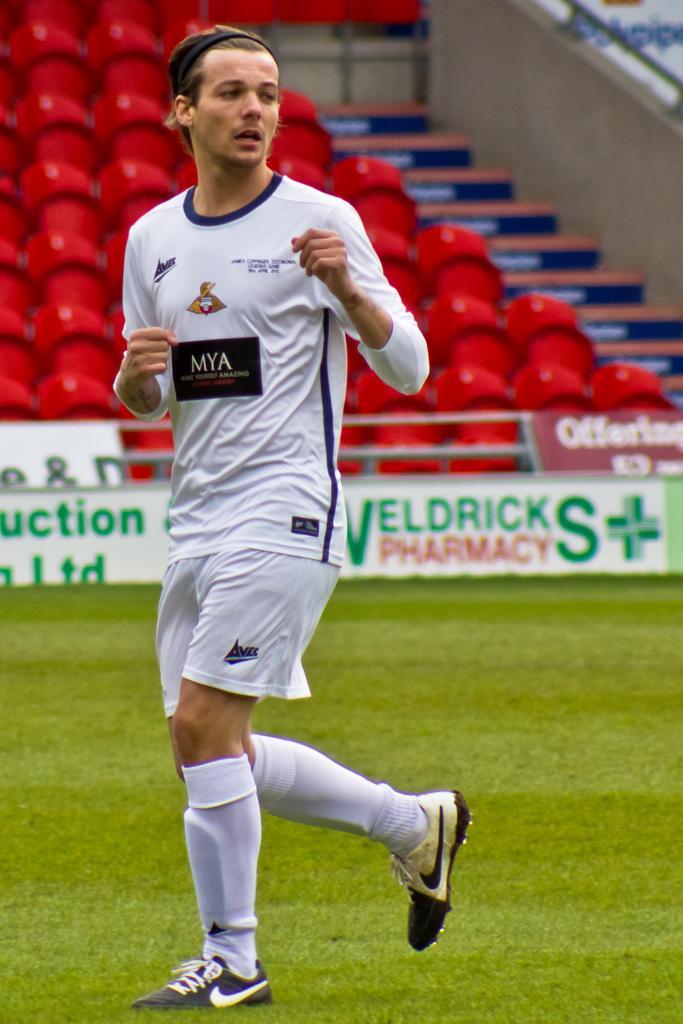Can you describe this image briefly? In this image we can see a person in a sports dress and we can see grass on the ground and in the background, we can see boards with the text and there are some chairs in the stadium. 